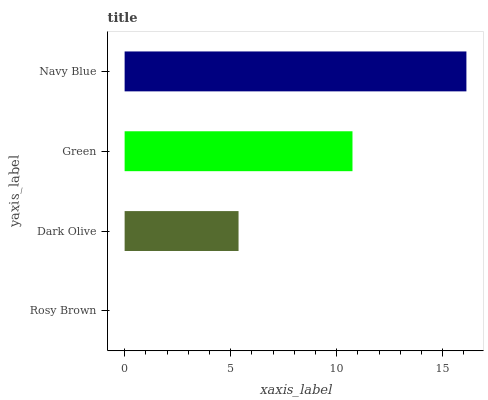Is Rosy Brown the minimum?
Answer yes or no. Yes. Is Navy Blue the maximum?
Answer yes or no. Yes. Is Dark Olive the minimum?
Answer yes or no. No. Is Dark Olive the maximum?
Answer yes or no. No. Is Dark Olive greater than Rosy Brown?
Answer yes or no. Yes. Is Rosy Brown less than Dark Olive?
Answer yes or no. Yes. Is Rosy Brown greater than Dark Olive?
Answer yes or no. No. Is Dark Olive less than Rosy Brown?
Answer yes or no. No. Is Green the high median?
Answer yes or no. Yes. Is Dark Olive the low median?
Answer yes or no. Yes. Is Dark Olive the high median?
Answer yes or no. No. Is Navy Blue the low median?
Answer yes or no. No. 